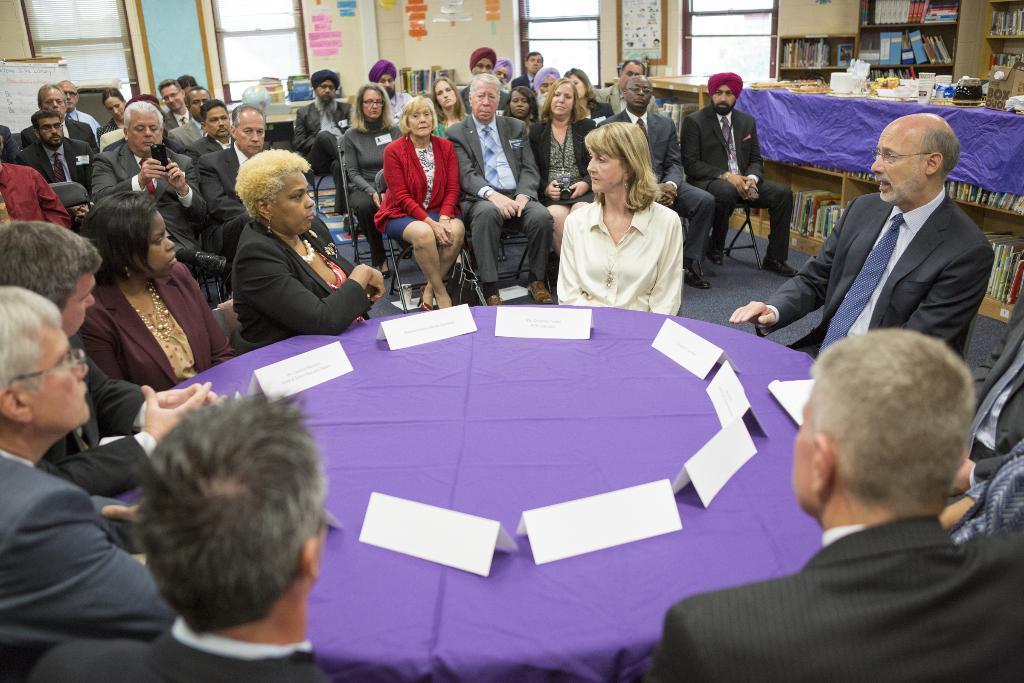Please provide a concise description of this image. There are group of people sitting on the chair. There is a table. There are cupboards,book racks,windows,charts and a cardboard box on the table. The person is holding a mobile on the left side. On the floor there is a mat. 